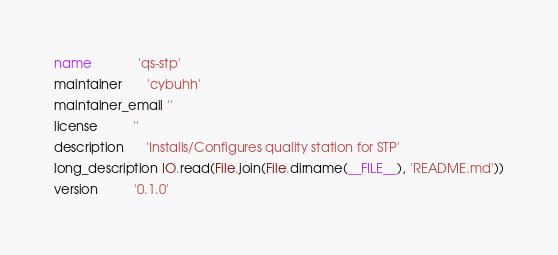<code> <loc_0><loc_0><loc_500><loc_500><_Ruby_>name             'qs-stp'
maintainer       'cybuhh'
maintainer_email ''
license          ''
description      'Installs/Configures quality station for STP'
long_description IO.read(File.join(File.dirname(__FILE__), 'README.md'))
version          '0.1.0'
</code> 